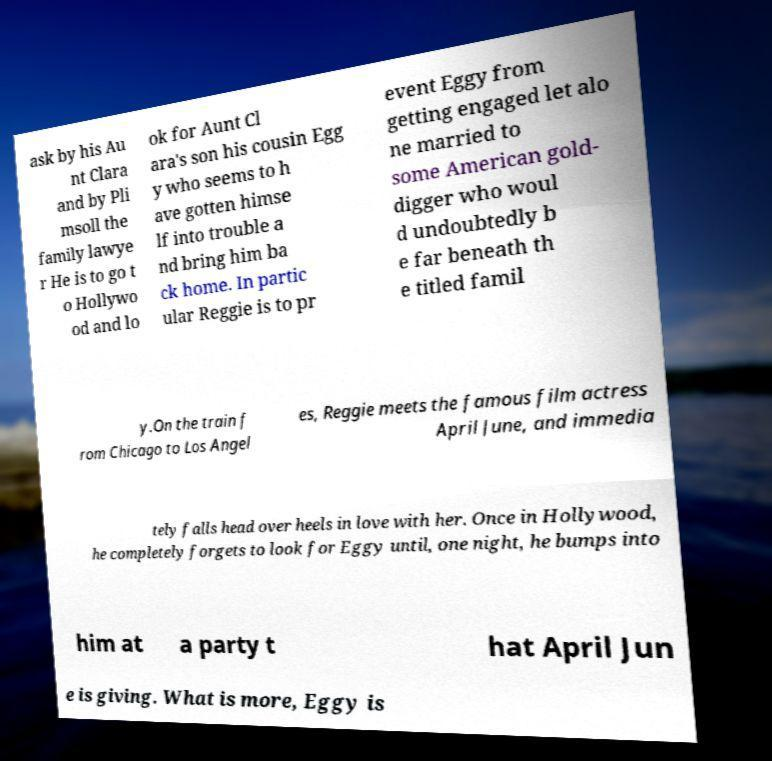Can you accurately transcribe the text from the provided image for me? ask by his Au nt Clara and by Pli msoll the family lawye r He is to go t o Hollywo od and lo ok for Aunt Cl ara's son his cousin Egg y who seems to h ave gotten himse lf into trouble a nd bring him ba ck home. In partic ular Reggie is to pr event Eggy from getting engaged let alo ne married to some American gold- digger who woul d undoubtedly b e far beneath th e titled famil y.On the train f rom Chicago to Los Angel es, Reggie meets the famous film actress April June, and immedia tely falls head over heels in love with her. Once in Hollywood, he completely forgets to look for Eggy until, one night, he bumps into him at a party t hat April Jun e is giving. What is more, Eggy is 